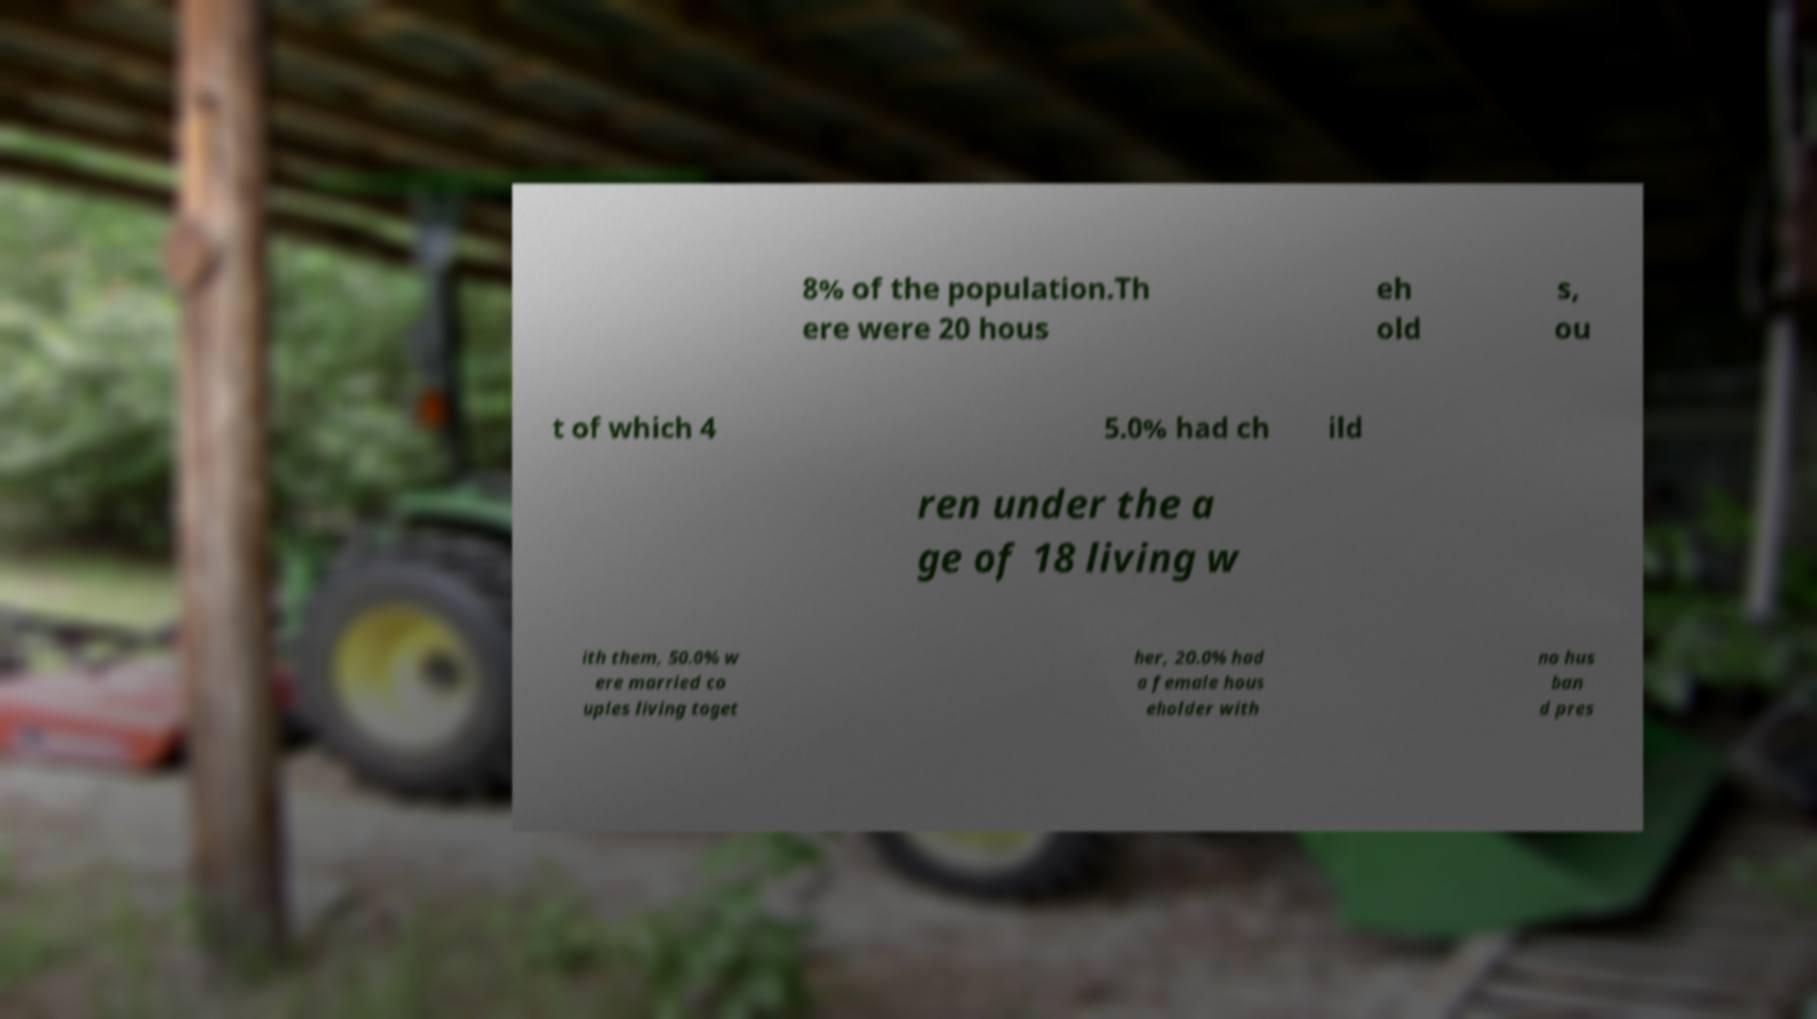Please read and relay the text visible in this image. What does it say? 8% of the population.Th ere were 20 hous eh old s, ou t of which 4 5.0% had ch ild ren under the a ge of 18 living w ith them, 50.0% w ere married co uples living toget her, 20.0% had a female hous eholder with no hus ban d pres 